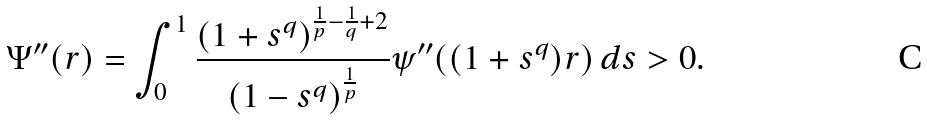<formula> <loc_0><loc_0><loc_500><loc_500>\Psi ^ { \prime \prime } ( r ) = \int _ { 0 } ^ { 1 } \frac { ( 1 + s ^ { q } ) ^ { \frac { 1 } { p } - \frac { 1 } { q } + 2 } } { ( 1 - s ^ { q } ) ^ { \frac { 1 } { p } } } \psi ^ { \prime \prime } ( ( 1 + s ^ { q } ) r ) \, d s > 0 .</formula> 